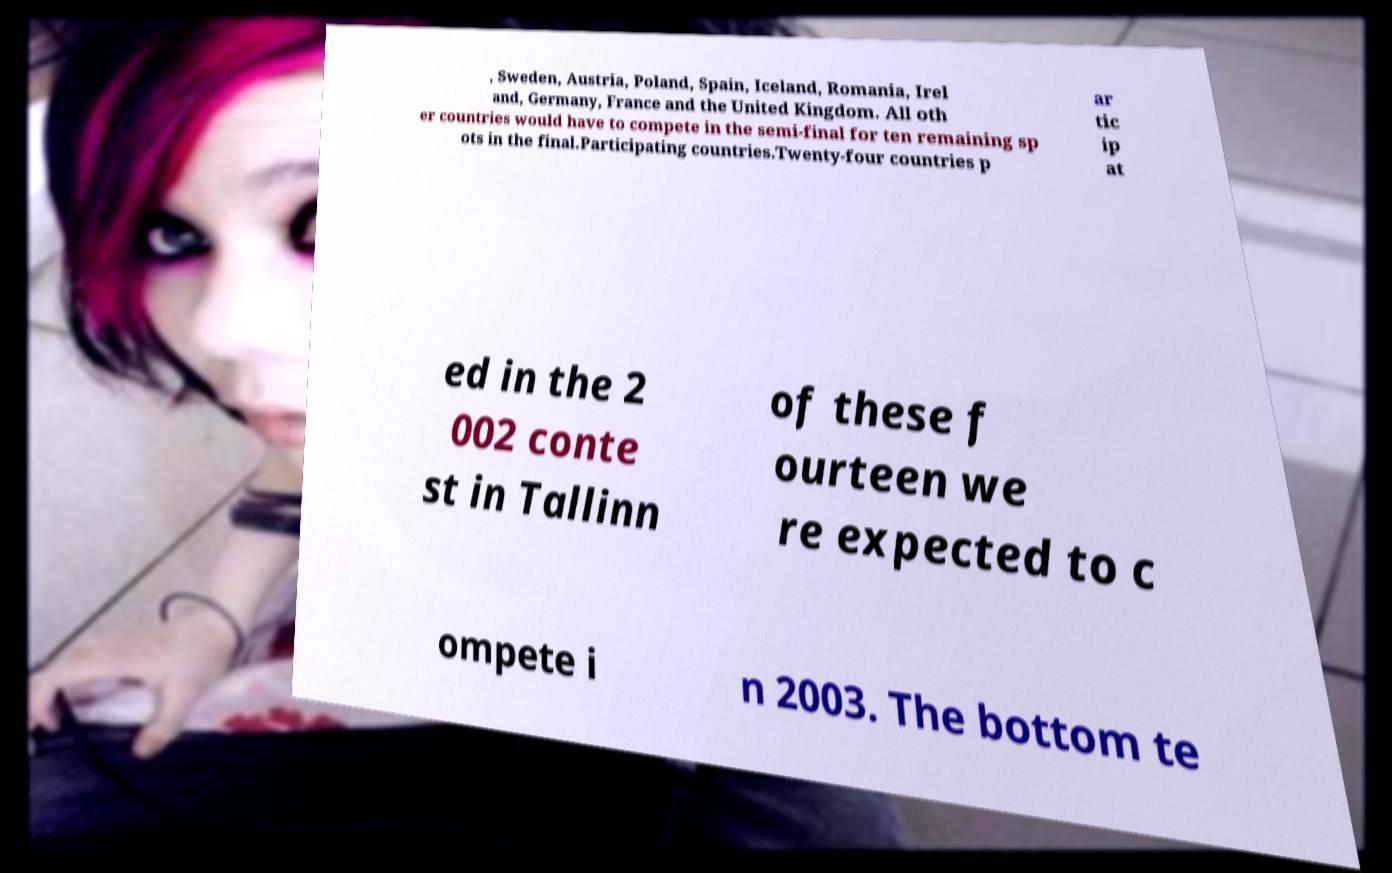What messages or text are displayed in this image? I need them in a readable, typed format. , Sweden, Austria, Poland, Spain, Iceland, Romania, Irel and, Germany, France and the United Kingdom. All oth er countries would have to compete in the semi-final for ten remaining sp ots in the final.Participating countries.Twenty-four countries p ar tic ip at ed in the 2 002 conte st in Tallinn of these f ourteen we re expected to c ompete i n 2003. The bottom te 